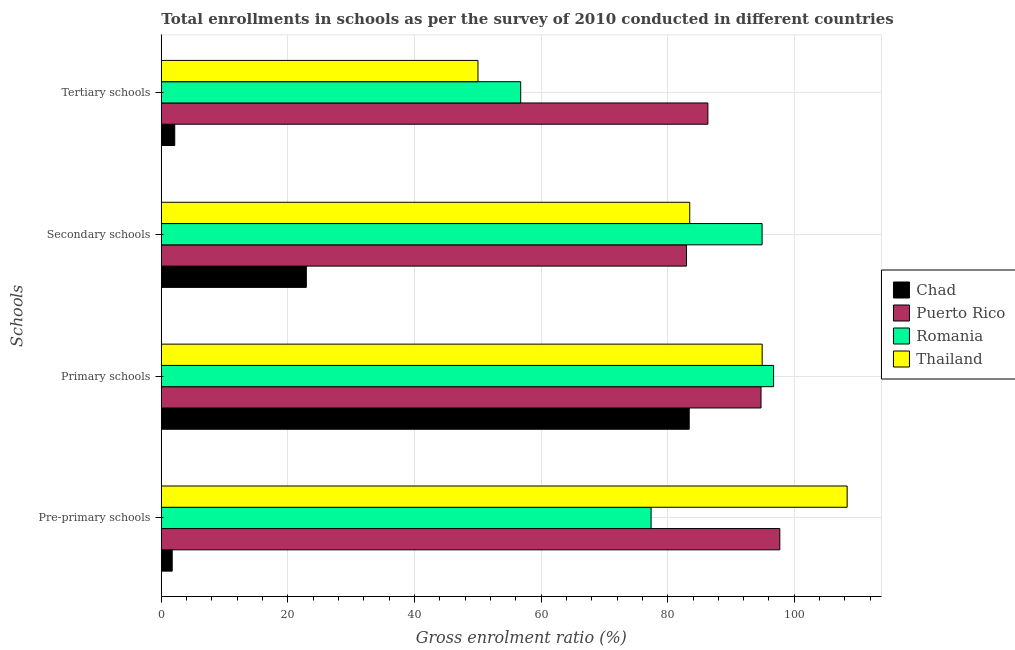How many groups of bars are there?
Give a very brief answer. 4. Are the number of bars per tick equal to the number of legend labels?
Provide a short and direct response. Yes. How many bars are there on the 3rd tick from the top?
Your response must be concise. 4. How many bars are there on the 4th tick from the bottom?
Your answer should be very brief. 4. What is the label of the 1st group of bars from the top?
Provide a short and direct response. Tertiary schools. What is the gross enrolment ratio in secondary schools in Romania?
Your answer should be compact. 94.91. Across all countries, what is the maximum gross enrolment ratio in secondary schools?
Ensure brevity in your answer.  94.91. Across all countries, what is the minimum gross enrolment ratio in pre-primary schools?
Your response must be concise. 1.72. In which country was the gross enrolment ratio in pre-primary schools maximum?
Offer a very short reply. Thailand. In which country was the gross enrolment ratio in secondary schools minimum?
Your answer should be compact. Chad. What is the total gross enrolment ratio in secondary schools in the graph?
Provide a succinct answer. 284.27. What is the difference between the gross enrolment ratio in pre-primary schools in Thailand and that in Puerto Rico?
Offer a terse response. 10.64. What is the difference between the gross enrolment ratio in secondary schools in Thailand and the gross enrolment ratio in primary schools in Puerto Rico?
Ensure brevity in your answer.  -11.26. What is the average gross enrolment ratio in secondary schools per country?
Your response must be concise. 71.07. What is the difference between the gross enrolment ratio in primary schools and gross enrolment ratio in pre-primary schools in Romania?
Keep it short and to the point. 19.35. What is the ratio of the gross enrolment ratio in pre-primary schools in Chad to that in Thailand?
Your answer should be compact. 0.02. Is the gross enrolment ratio in secondary schools in Chad less than that in Romania?
Give a very brief answer. Yes. Is the difference between the gross enrolment ratio in pre-primary schools in Romania and Puerto Rico greater than the difference between the gross enrolment ratio in primary schools in Romania and Puerto Rico?
Your answer should be very brief. No. What is the difference between the highest and the second highest gross enrolment ratio in secondary schools?
Give a very brief answer. 11.43. What is the difference between the highest and the lowest gross enrolment ratio in tertiary schools?
Keep it short and to the point. 84.22. In how many countries, is the gross enrolment ratio in secondary schools greater than the average gross enrolment ratio in secondary schools taken over all countries?
Ensure brevity in your answer.  3. Is the sum of the gross enrolment ratio in pre-primary schools in Chad and Romania greater than the maximum gross enrolment ratio in primary schools across all countries?
Offer a terse response. No. What does the 4th bar from the top in Primary schools represents?
Provide a succinct answer. Chad. What does the 3rd bar from the bottom in Primary schools represents?
Give a very brief answer. Romania. Is it the case that in every country, the sum of the gross enrolment ratio in pre-primary schools and gross enrolment ratio in primary schools is greater than the gross enrolment ratio in secondary schools?
Your answer should be very brief. Yes. How many bars are there?
Ensure brevity in your answer.  16. Does the graph contain any zero values?
Your response must be concise. No. How many legend labels are there?
Your answer should be compact. 4. How are the legend labels stacked?
Offer a very short reply. Vertical. What is the title of the graph?
Keep it short and to the point. Total enrollments in schools as per the survey of 2010 conducted in different countries. Does "Eritrea" appear as one of the legend labels in the graph?
Offer a terse response. No. What is the label or title of the Y-axis?
Make the answer very short. Schools. What is the Gross enrolment ratio (%) in Chad in Pre-primary schools?
Offer a very short reply. 1.72. What is the Gross enrolment ratio (%) in Puerto Rico in Pre-primary schools?
Your answer should be compact. 97.71. What is the Gross enrolment ratio (%) in Romania in Pre-primary schools?
Provide a succinct answer. 77.38. What is the Gross enrolment ratio (%) of Thailand in Pre-primary schools?
Give a very brief answer. 108.35. What is the Gross enrolment ratio (%) of Chad in Primary schools?
Provide a succinct answer. 83.4. What is the Gross enrolment ratio (%) of Puerto Rico in Primary schools?
Provide a short and direct response. 94.74. What is the Gross enrolment ratio (%) of Romania in Primary schools?
Keep it short and to the point. 96.73. What is the Gross enrolment ratio (%) in Thailand in Primary schools?
Your answer should be compact. 94.92. What is the Gross enrolment ratio (%) of Chad in Secondary schools?
Keep it short and to the point. 22.91. What is the Gross enrolment ratio (%) of Puerto Rico in Secondary schools?
Offer a terse response. 82.97. What is the Gross enrolment ratio (%) of Romania in Secondary schools?
Your response must be concise. 94.91. What is the Gross enrolment ratio (%) of Thailand in Secondary schools?
Ensure brevity in your answer.  83.48. What is the Gross enrolment ratio (%) in Chad in Tertiary schools?
Your answer should be very brief. 2.12. What is the Gross enrolment ratio (%) in Puerto Rico in Tertiary schools?
Keep it short and to the point. 86.35. What is the Gross enrolment ratio (%) of Romania in Tertiary schools?
Give a very brief answer. 56.78. What is the Gross enrolment ratio (%) of Thailand in Tertiary schools?
Your response must be concise. 50.03. Across all Schools, what is the maximum Gross enrolment ratio (%) in Chad?
Keep it short and to the point. 83.4. Across all Schools, what is the maximum Gross enrolment ratio (%) of Puerto Rico?
Your answer should be very brief. 97.71. Across all Schools, what is the maximum Gross enrolment ratio (%) of Romania?
Provide a short and direct response. 96.73. Across all Schools, what is the maximum Gross enrolment ratio (%) of Thailand?
Keep it short and to the point. 108.35. Across all Schools, what is the minimum Gross enrolment ratio (%) of Chad?
Your answer should be compact. 1.72. Across all Schools, what is the minimum Gross enrolment ratio (%) in Puerto Rico?
Provide a succinct answer. 82.97. Across all Schools, what is the minimum Gross enrolment ratio (%) in Romania?
Keep it short and to the point. 56.78. Across all Schools, what is the minimum Gross enrolment ratio (%) of Thailand?
Offer a very short reply. 50.03. What is the total Gross enrolment ratio (%) in Chad in the graph?
Provide a succinct answer. 110.15. What is the total Gross enrolment ratio (%) of Puerto Rico in the graph?
Keep it short and to the point. 361.77. What is the total Gross enrolment ratio (%) of Romania in the graph?
Your response must be concise. 325.79. What is the total Gross enrolment ratio (%) in Thailand in the graph?
Provide a succinct answer. 336.78. What is the difference between the Gross enrolment ratio (%) of Chad in Pre-primary schools and that in Primary schools?
Provide a succinct answer. -81.68. What is the difference between the Gross enrolment ratio (%) in Puerto Rico in Pre-primary schools and that in Primary schools?
Provide a succinct answer. 2.97. What is the difference between the Gross enrolment ratio (%) in Romania in Pre-primary schools and that in Primary schools?
Keep it short and to the point. -19.35. What is the difference between the Gross enrolment ratio (%) of Thailand in Pre-primary schools and that in Primary schools?
Keep it short and to the point. 13.42. What is the difference between the Gross enrolment ratio (%) of Chad in Pre-primary schools and that in Secondary schools?
Offer a terse response. -21.19. What is the difference between the Gross enrolment ratio (%) of Puerto Rico in Pre-primary schools and that in Secondary schools?
Your answer should be very brief. 14.74. What is the difference between the Gross enrolment ratio (%) of Romania in Pre-primary schools and that in Secondary schools?
Keep it short and to the point. -17.53. What is the difference between the Gross enrolment ratio (%) in Thailand in Pre-primary schools and that in Secondary schools?
Your response must be concise. 24.87. What is the difference between the Gross enrolment ratio (%) of Chad in Pre-primary schools and that in Tertiary schools?
Offer a terse response. -0.4. What is the difference between the Gross enrolment ratio (%) in Puerto Rico in Pre-primary schools and that in Tertiary schools?
Your answer should be compact. 11.36. What is the difference between the Gross enrolment ratio (%) of Romania in Pre-primary schools and that in Tertiary schools?
Your answer should be compact. 20.6. What is the difference between the Gross enrolment ratio (%) of Thailand in Pre-primary schools and that in Tertiary schools?
Your answer should be very brief. 58.32. What is the difference between the Gross enrolment ratio (%) in Chad in Primary schools and that in Secondary schools?
Make the answer very short. 60.49. What is the difference between the Gross enrolment ratio (%) of Puerto Rico in Primary schools and that in Secondary schools?
Give a very brief answer. 11.77. What is the difference between the Gross enrolment ratio (%) of Romania in Primary schools and that in Secondary schools?
Your answer should be very brief. 1.82. What is the difference between the Gross enrolment ratio (%) in Thailand in Primary schools and that in Secondary schools?
Make the answer very short. 11.44. What is the difference between the Gross enrolment ratio (%) of Chad in Primary schools and that in Tertiary schools?
Ensure brevity in your answer.  81.28. What is the difference between the Gross enrolment ratio (%) of Puerto Rico in Primary schools and that in Tertiary schools?
Your response must be concise. 8.4. What is the difference between the Gross enrolment ratio (%) in Romania in Primary schools and that in Tertiary schools?
Give a very brief answer. 39.95. What is the difference between the Gross enrolment ratio (%) in Thailand in Primary schools and that in Tertiary schools?
Make the answer very short. 44.9. What is the difference between the Gross enrolment ratio (%) of Chad in Secondary schools and that in Tertiary schools?
Provide a short and direct response. 20.79. What is the difference between the Gross enrolment ratio (%) of Puerto Rico in Secondary schools and that in Tertiary schools?
Offer a terse response. -3.38. What is the difference between the Gross enrolment ratio (%) of Romania in Secondary schools and that in Tertiary schools?
Offer a very short reply. 38.13. What is the difference between the Gross enrolment ratio (%) in Thailand in Secondary schools and that in Tertiary schools?
Make the answer very short. 33.45. What is the difference between the Gross enrolment ratio (%) of Chad in Pre-primary schools and the Gross enrolment ratio (%) of Puerto Rico in Primary schools?
Your answer should be compact. -93.02. What is the difference between the Gross enrolment ratio (%) of Chad in Pre-primary schools and the Gross enrolment ratio (%) of Romania in Primary schools?
Offer a terse response. -95.01. What is the difference between the Gross enrolment ratio (%) in Chad in Pre-primary schools and the Gross enrolment ratio (%) in Thailand in Primary schools?
Offer a very short reply. -93.2. What is the difference between the Gross enrolment ratio (%) of Puerto Rico in Pre-primary schools and the Gross enrolment ratio (%) of Romania in Primary schools?
Offer a very short reply. 0.98. What is the difference between the Gross enrolment ratio (%) in Puerto Rico in Pre-primary schools and the Gross enrolment ratio (%) in Thailand in Primary schools?
Make the answer very short. 2.79. What is the difference between the Gross enrolment ratio (%) of Romania in Pre-primary schools and the Gross enrolment ratio (%) of Thailand in Primary schools?
Keep it short and to the point. -17.55. What is the difference between the Gross enrolment ratio (%) of Chad in Pre-primary schools and the Gross enrolment ratio (%) of Puerto Rico in Secondary schools?
Your answer should be very brief. -81.25. What is the difference between the Gross enrolment ratio (%) in Chad in Pre-primary schools and the Gross enrolment ratio (%) in Romania in Secondary schools?
Keep it short and to the point. -93.19. What is the difference between the Gross enrolment ratio (%) of Chad in Pre-primary schools and the Gross enrolment ratio (%) of Thailand in Secondary schools?
Give a very brief answer. -81.76. What is the difference between the Gross enrolment ratio (%) in Puerto Rico in Pre-primary schools and the Gross enrolment ratio (%) in Romania in Secondary schools?
Give a very brief answer. 2.8. What is the difference between the Gross enrolment ratio (%) in Puerto Rico in Pre-primary schools and the Gross enrolment ratio (%) in Thailand in Secondary schools?
Offer a terse response. 14.23. What is the difference between the Gross enrolment ratio (%) of Romania in Pre-primary schools and the Gross enrolment ratio (%) of Thailand in Secondary schools?
Provide a short and direct response. -6.1. What is the difference between the Gross enrolment ratio (%) of Chad in Pre-primary schools and the Gross enrolment ratio (%) of Puerto Rico in Tertiary schools?
Your response must be concise. -84.63. What is the difference between the Gross enrolment ratio (%) of Chad in Pre-primary schools and the Gross enrolment ratio (%) of Romania in Tertiary schools?
Keep it short and to the point. -55.06. What is the difference between the Gross enrolment ratio (%) of Chad in Pre-primary schools and the Gross enrolment ratio (%) of Thailand in Tertiary schools?
Make the answer very short. -48.31. What is the difference between the Gross enrolment ratio (%) in Puerto Rico in Pre-primary schools and the Gross enrolment ratio (%) in Romania in Tertiary schools?
Offer a terse response. 40.93. What is the difference between the Gross enrolment ratio (%) in Puerto Rico in Pre-primary schools and the Gross enrolment ratio (%) in Thailand in Tertiary schools?
Your answer should be compact. 47.68. What is the difference between the Gross enrolment ratio (%) of Romania in Pre-primary schools and the Gross enrolment ratio (%) of Thailand in Tertiary schools?
Your answer should be very brief. 27.35. What is the difference between the Gross enrolment ratio (%) in Chad in Primary schools and the Gross enrolment ratio (%) in Puerto Rico in Secondary schools?
Ensure brevity in your answer.  0.43. What is the difference between the Gross enrolment ratio (%) in Chad in Primary schools and the Gross enrolment ratio (%) in Romania in Secondary schools?
Your answer should be very brief. -11.51. What is the difference between the Gross enrolment ratio (%) in Chad in Primary schools and the Gross enrolment ratio (%) in Thailand in Secondary schools?
Ensure brevity in your answer.  -0.08. What is the difference between the Gross enrolment ratio (%) of Puerto Rico in Primary schools and the Gross enrolment ratio (%) of Romania in Secondary schools?
Offer a very short reply. -0.17. What is the difference between the Gross enrolment ratio (%) of Puerto Rico in Primary schools and the Gross enrolment ratio (%) of Thailand in Secondary schools?
Keep it short and to the point. 11.26. What is the difference between the Gross enrolment ratio (%) of Romania in Primary schools and the Gross enrolment ratio (%) of Thailand in Secondary schools?
Make the answer very short. 13.25. What is the difference between the Gross enrolment ratio (%) in Chad in Primary schools and the Gross enrolment ratio (%) in Puerto Rico in Tertiary schools?
Provide a short and direct response. -2.95. What is the difference between the Gross enrolment ratio (%) of Chad in Primary schools and the Gross enrolment ratio (%) of Romania in Tertiary schools?
Give a very brief answer. 26.62. What is the difference between the Gross enrolment ratio (%) of Chad in Primary schools and the Gross enrolment ratio (%) of Thailand in Tertiary schools?
Make the answer very short. 33.37. What is the difference between the Gross enrolment ratio (%) of Puerto Rico in Primary schools and the Gross enrolment ratio (%) of Romania in Tertiary schools?
Give a very brief answer. 37.97. What is the difference between the Gross enrolment ratio (%) of Puerto Rico in Primary schools and the Gross enrolment ratio (%) of Thailand in Tertiary schools?
Your answer should be compact. 44.72. What is the difference between the Gross enrolment ratio (%) in Romania in Primary schools and the Gross enrolment ratio (%) in Thailand in Tertiary schools?
Make the answer very short. 46.7. What is the difference between the Gross enrolment ratio (%) of Chad in Secondary schools and the Gross enrolment ratio (%) of Puerto Rico in Tertiary schools?
Provide a short and direct response. -63.44. What is the difference between the Gross enrolment ratio (%) in Chad in Secondary schools and the Gross enrolment ratio (%) in Romania in Tertiary schools?
Make the answer very short. -33.87. What is the difference between the Gross enrolment ratio (%) in Chad in Secondary schools and the Gross enrolment ratio (%) in Thailand in Tertiary schools?
Ensure brevity in your answer.  -27.12. What is the difference between the Gross enrolment ratio (%) in Puerto Rico in Secondary schools and the Gross enrolment ratio (%) in Romania in Tertiary schools?
Give a very brief answer. 26.19. What is the difference between the Gross enrolment ratio (%) in Puerto Rico in Secondary schools and the Gross enrolment ratio (%) in Thailand in Tertiary schools?
Make the answer very short. 32.94. What is the difference between the Gross enrolment ratio (%) of Romania in Secondary schools and the Gross enrolment ratio (%) of Thailand in Tertiary schools?
Make the answer very short. 44.88. What is the average Gross enrolment ratio (%) in Chad per Schools?
Make the answer very short. 27.54. What is the average Gross enrolment ratio (%) in Puerto Rico per Schools?
Keep it short and to the point. 90.44. What is the average Gross enrolment ratio (%) of Romania per Schools?
Offer a terse response. 81.45. What is the average Gross enrolment ratio (%) in Thailand per Schools?
Keep it short and to the point. 84.19. What is the difference between the Gross enrolment ratio (%) in Chad and Gross enrolment ratio (%) in Puerto Rico in Pre-primary schools?
Provide a short and direct response. -95.99. What is the difference between the Gross enrolment ratio (%) in Chad and Gross enrolment ratio (%) in Romania in Pre-primary schools?
Make the answer very short. -75.66. What is the difference between the Gross enrolment ratio (%) in Chad and Gross enrolment ratio (%) in Thailand in Pre-primary schools?
Provide a short and direct response. -106.63. What is the difference between the Gross enrolment ratio (%) in Puerto Rico and Gross enrolment ratio (%) in Romania in Pre-primary schools?
Your answer should be very brief. 20.33. What is the difference between the Gross enrolment ratio (%) in Puerto Rico and Gross enrolment ratio (%) in Thailand in Pre-primary schools?
Provide a short and direct response. -10.64. What is the difference between the Gross enrolment ratio (%) in Romania and Gross enrolment ratio (%) in Thailand in Pre-primary schools?
Provide a short and direct response. -30.97. What is the difference between the Gross enrolment ratio (%) of Chad and Gross enrolment ratio (%) of Puerto Rico in Primary schools?
Provide a succinct answer. -11.34. What is the difference between the Gross enrolment ratio (%) of Chad and Gross enrolment ratio (%) of Romania in Primary schools?
Give a very brief answer. -13.33. What is the difference between the Gross enrolment ratio (%) of Chad and Gross enrolment ratio (%) of Thailand in Primary schools?
Ensure brevity in your answer.  -11.52. What is the difference between the Gross enrolment ratio (%) in Puerto Rico and Gross enrolment ratio (%) in Romania in Primary schools?
Give a very brief answer. -1.98. What is the difference between the Gross enrolment ratio (%) in Puerto Rico and Gross enrolment ratio (%) in Thailand in Primary schools?
Your answer should be compact. -0.18. What is the difference between the Gross enrolment ratio (%) of Romania and Gross enrolment ratio (%) of Thailand in Primary schools?
Keep it short and to the point. 1.8. What is the difference between the Gross enrolment ratio (%) of Chad and Gross enrolment ratio (%) of Puerto Rico in Secondary schools?
Your response must be concise. -60.06. What is the difference between the Gross enrolment ratio (%) in Chad and Gross enrolment ratio (%) in Romania in Secondary schools?
Offer a terse response. -72. What is the difference between the Gross enrolment ratio (%) in Chad and Gross enrolment ratio (%) in Thailand in Secondary schools?
Give a very brief answer. -60.57. What is the difference between the Gross enrolment ratio (%) of Puerto Rico and Gross enrolment ratio (%) of Romania in Secondary schools?
Provide a succinct answer. -11.94. What is the difference between the Gross enrolment ratio (%) in Puerto Rico and Gross enrolment ratio (%) in Thailand in Secondary schools?
Your answer should be very brief. -0.51. What is the difference between the Gross enrolment ratio (%) in Romania and Gross enrolment ratio (%) in Thailand in Secondary schools?
Your response must be concise. 11.43. What is the difference between the Gross enrolment ratio (%) of Chad and Gross enrolment ratio (%) of Puerto Rico in Tertiary schools?
Provide a short and direct response. -84.22. What is the difference between the Gross enrolment ratio (%) of Chad and Gross enrolment ratio (%) of Romania in Tertiary schools?
Your answer should be compact. -54.65. What is the difference between the Gross enrolment ratio (%) of Chad and Gross enrolment ratio (%) of Thailand in Tertiary schools?
Provide a succinct answer. -47.9. What is the difference between the Gross enrolment ratio (%) of Puerto Rico and Gross enrolment ratio (%) of Romania in Tertiary schools?
Your response must be concise. 29.57. What is the difference between the Gross enrolment ratio (%) in Puerto Rico and Gross enrolment ratio (%) in Thailand in Tertiary schools?
Your answer should be very brief. 36.32. What is the difference between the Gross enrolment ratio (%) of Romania and Gross enrolment ratio (%) of Thailand in Tertiary schools?
Give a very brief answer. 6.75. What is the ratio of the Gross enrolment ratio (%) of Chad in Pre-primary schools to that in Primary schools?
Your response must be concise. 0.02. What is the ratio of the Gross enrolment ratio (%) in Puerto Rico in Pre-primary schools to that in Primary schools?
Offer a terse response. 1.03. What is the ratio of the Gross enrolment ratio (%) in Romania in Pre-primary schools to that in Primary schools?
Offer a terse response. 0.8. What is the ratio of the Gross enrolment ratio (%) of Thailand in Pre-primary schools to that in Primary schools?
Offer a terse response. 1.14. What is the ratio of the Gross enrolment ratio (%) in Chad in Pre-primary schools to that in Secondary schools?
Make the answer very short. 0.08. What is the ratio of the Gross enrolment ratio (%) of Puerto Rico in Pre-primary schools to that in Secondary schools?
Offer a very short reply. 1.18. What is the ratio of the Gross enrolment ratio (%) in Romania in Pre-primary schools to that in Secondary schools?
Offer a very short reply. 0.82. What is the ratio of the Gross enrolment ratio (%) in Thailand in Pre-primary schools to that in Secondary schools?
Your answer should be compact. 1.3. What is the ratio of the Gross enrolment ratio (%) in Chad in Pre-primary schools to that in Tertiary schools?
Provide a short and direct response. 0.81. What is the ratio of the Gross enrolment ratio (%) in Puerto Rico in Pre-primary schools to that in Tertiary schools?
Ensure brevity in your answer.  1.13. What is the ratio of the Gross enrolment ratio (%) of Romania in Pre-primary schools to that in Tertiary schools?
Provide a short and direct response. 1.36. What is the ratio of the Gross enrolment ratio (%) in Thailand in Pre-primary schools to that in Tertiary schools?
Your answer should be compact. 2.17. What is the ratio of the Gross enrolment ratio (%) of Chad in Primary schools to that in Secondary schools?
Make the answer very short. 3.64. What is the ratio of the Gross enrolment ratio (%) of Puerto Rico in Primary schools to that in Secondary schools?
Your response must be concise. 1.14. What is the ratio of the Gross enrolment ratio (%) in Romania in Primary schools to that in Secondary schools?
Your answer should be compact. 1.02. What is the ratio of the Gross enrolment ratio (%) of Thailand in Primary schools to that in Secondary schools?
Make the answer very short. 1.14. What is the ratio of the Gross enrolment ratio (%) in Chad in Primary schools to that in Tertiary schools?
Offer a terse response. 39.3. What is the ratio of the Gross enrolment ratio (%) in Puerto Rico in Primary schools to that in Tertiary schools?
Offer a terse response. 1.1. What is the ratio of the Gross enrolment ratio (%) of Romania in Primary schools to that in Tertiary schools?
Provide a succinct answer. 1.7. What is the ratio of the Gross enrolment ratio (%) of Thailand in Primary schools to that in Tertiary schools?
Keep it short and to the point. 1.9. What is the ratio of the Gross enrolment ratio (%) in Chad in Secondary schools to that in Tertiary schools?
Offer a very short reply. 10.8. What is the ratio of the Gross enrolment ratio (%) of Puerto Rico in Secondary schools to that in Tertiary schools?
Keep it short and to the point. 0.96. What is the ratio of the Gross enrolment ratio (%) in Romania in Secondary schools to that in Tertiary schools?
Your answer should be very brief. 1.67. What is the ratio of the Gross enrolment ratio (%) in Thailand in Secondary schools to that in Tertiary schools?
Make the answer very short. 1.67. What is the difference between the highest and the second highest Gross enrolment ratio (%) of Chad?
Offer a terse response. 60.49. What is the difference between the highest and the second highest Gross enrolment ratio (%) in Puerto Rico?
Provide a succinct answer. 2.97. What is the difference between the highest and the second highest Gross enrolment ratio (%) of Romania?
Provide a succinct answer. 1.82. What is the difference between the highest and the second highest Gross enrolment ratio (%) of Thailand?
Your answer should be very brief. 13.42. What is the difference between the highest and the lowest Gross enrolment ratio (%) of Chad?
Provide a short and direct response. 81.68. What is the difference between the highest and the lowest Gross enrolment ratio (%) of Puerto Rico?
Make the answer very short. 14.74. What is the difference between the highest and the lowest Gross enrolment ratio (%) of Romania?
Ensure brevity in your answer.  39.95. What is the difference between the highest and the lowest Gross enrolment ratio (%) in Thailand?
Provide a short and direct response. 58.32. 